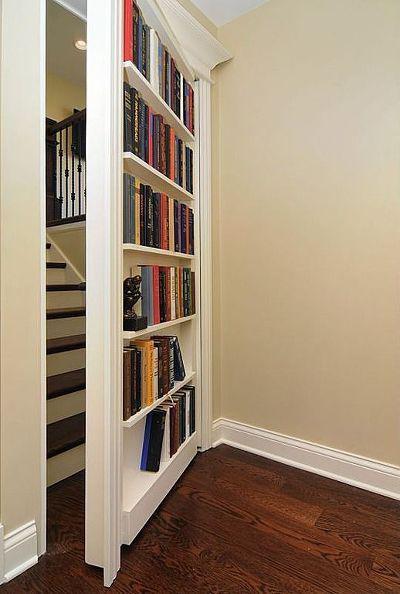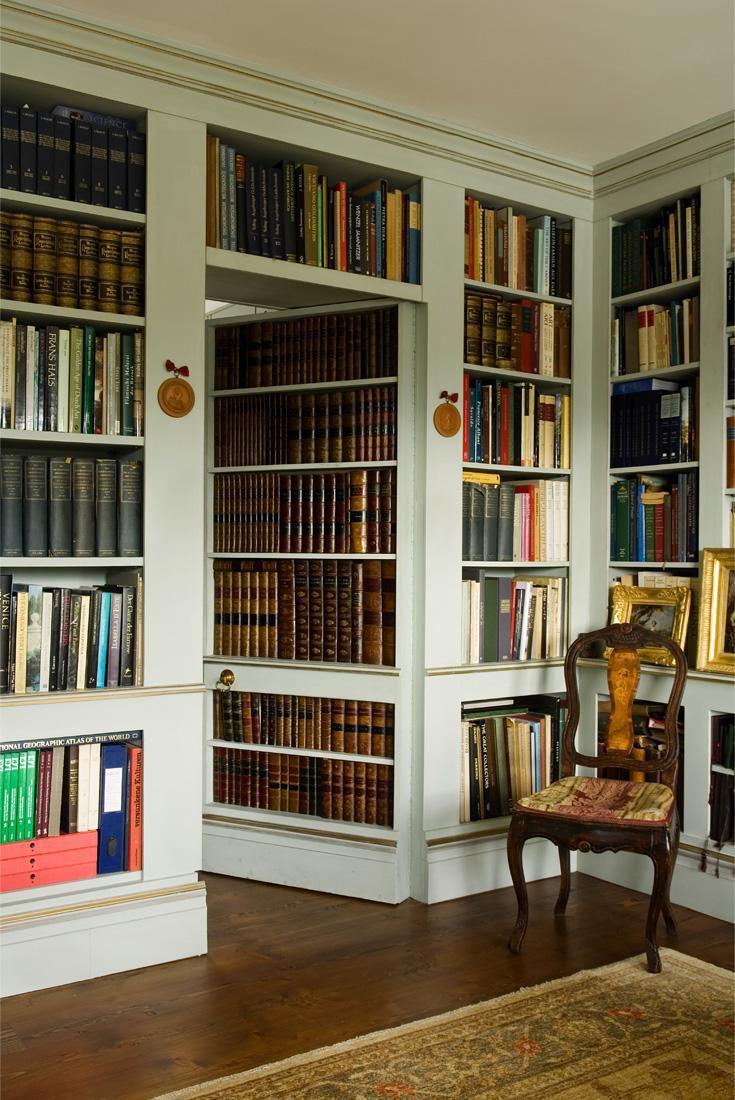The first image is the image on the left, the second image is the image on the right. Given the left and right images, does the statement "There is at least one chair near the bookshelves." hold true? Answer yes or no. Yes. 